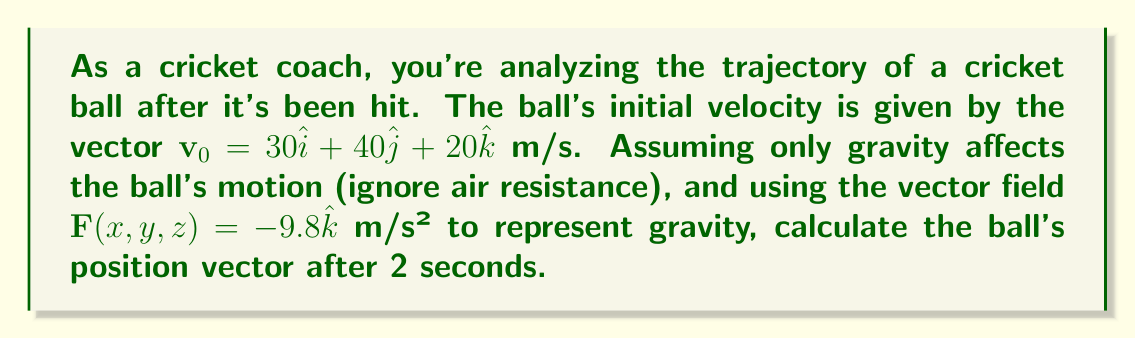Help me with this question. Let's approach this step-by-step:

1) The trajectory of the cricket ball can be described using kinematics equations, where the acceleration is constant and given by the gravitational field.

2) The position vector $\mathbf{r}(t)$ at time $t$ is given by:

   $$\mathbf{r}(t) = \mathbf{r}_0 + \mathbf{v}_0t + \frac{1}{2}\mathbf{a}t^2$$

   where $\mathbf{r}_0$ is the initial position, $\mathbf{v}_0$ is the initial velocity, and $\mathbf{a}$ is the acceleration.

3) We're given $\mathbf{v}_0 = 30\hat{i} + 40\hat{j} + 20\hat{k}$ m/s.

4) The acceleration $\mathbf{a}$ is given by the gravitational field $\mathbf{F}(x,y,z) = -9.8\hat{k}$ m/s².

5) Assuming the ball is hit from ground level, we can set $\mathbf{r}_0 = 0$.

6) Now, let's substitute these into our equation:

   $$\mathbf{r}(t) = (30\hat{i} + 40\hat{j} + 20\hat{k})t + \frac{1}{2}(-9.8\hat{k})t^2$$

7) We need to find $\mathbf{r}(2)$, so let's substitute $t=2$:

   $$\mathbf{r}(2) = (30\hat{i} + 40\hat{j} + 20\hat{k})(2) + \frac{1}{2}(-9.8\hat{k})(2)^2$$

8) Simplify:

   $$\mathbf{r}(2) = 60\hat{i} + 80\hat{j} + 40\hat{k} - 19.6\hat{k}$$

9) Combine like terms:

   $$\mathbf{r}(2) = 60\hat{i} + 80\hat{j} + 20.4\hat{k}$$

This gives us the position vector after 2 seconds.
Answer: $60\hat{i} + 80\hat{j} + 20.4\hat{k}$ m 